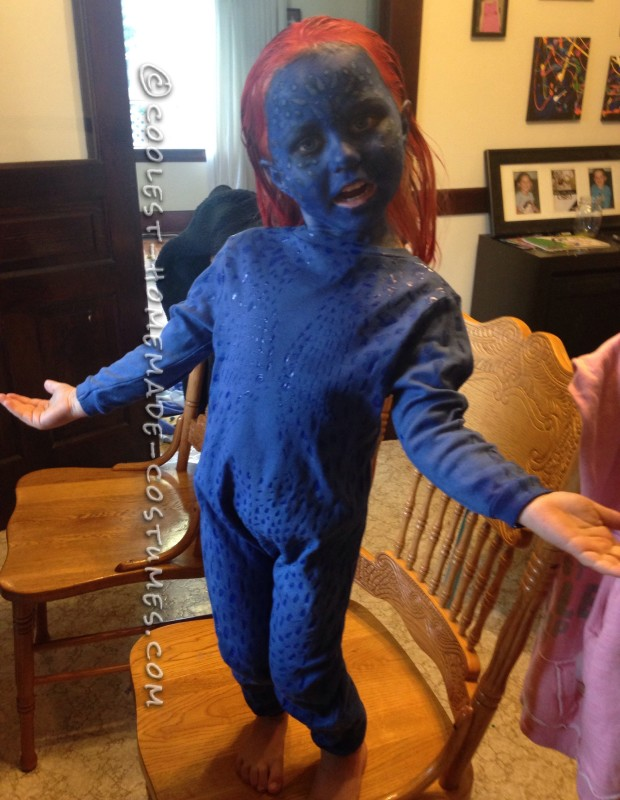Can you describe some fun facts about the character this costume is based on? Absolutely! This costume seems to be inspired by a character known for their unique blue skin and red hair, most likely from a popular comic book or movie series. Characters with distinctive appearances often have fascinating backstories and abilities. For instance, similar characters in comic books might possess mutant abilities, shapeshifting powers, or enhanced agility and strength. Their complex personalities and histories often make them beloved by fans. What are some potential challenges someone might face while wearing this costume? Wearing such a costume could present several challenges. Firstly, maintaining the blue face paint and prosthetics could be difficult, especially if it’s hot or if the wearer sweats. The costume could also be somewhat restrictive, making movement slightly more difficult. Additionally, if not made from breathable materials, it might become uncomfortable after a while. Ensuring that all materials used are hypoallergenic and comfortable for long periods is crucial. 